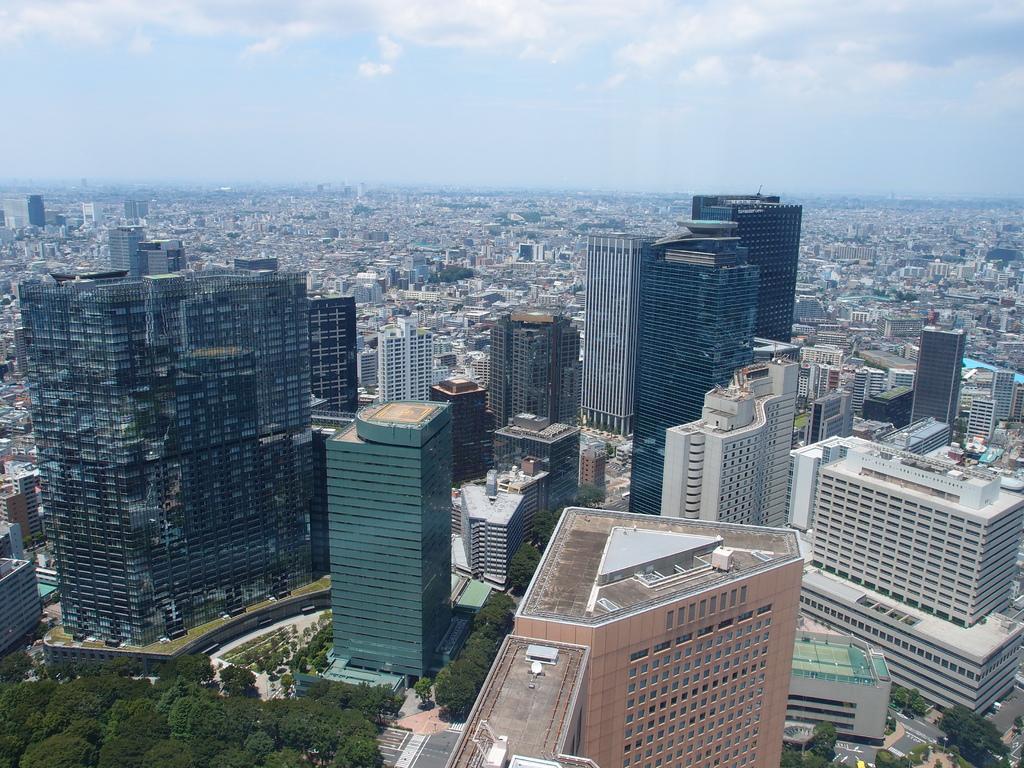Could you give a brief overview of what you see in this image? In this image we can see buildings, trees. At the top of the image there is sky and clouds. 